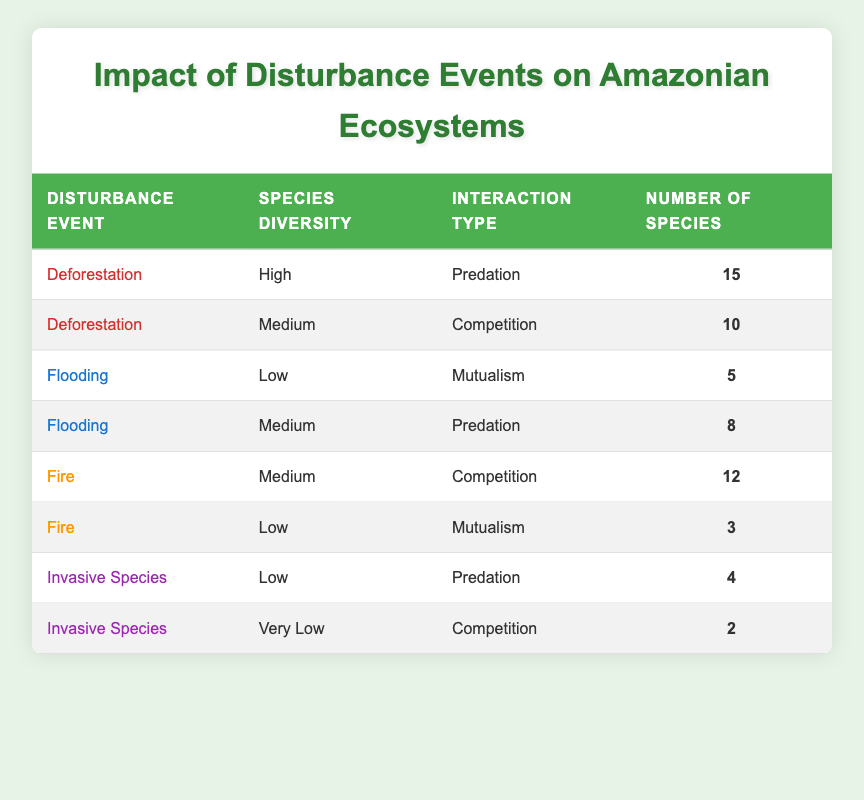What is the number of species associated with the Deforestation event and Predation interaction type? To find the answer, look for the row in the table under Deforestation for the Interaction Type of Predation. That row indicates there are 15 species.
Answer: 15 How many species are involved in the Medium Species Diversity category under Flooding? Check the rows under Flooding for the Species Diversity category labeled Medium. There is one row corresponding to this, showing that there are 8 species.
Answer: 8 Is there a higher number of species recorded under Fire for Competition or Mutualism interaction types? Review the rows for Fire. The Competition interaction shows 12 species while Mutualism shows only 3 species. Therefore, 12 is greater than 3.
Answer: Competition How many species are recorded across all categories for the Invasive Species disturbance event? For the Invasive Species event, look at the number of species in both rows. Adding these together (4 from Predation and 2 from Competition) gives a total of 6 species.
Answer: 6 What is the diversity status of species associated with Flooding and Mutualism? Look at the row under Flooding with the Interaction Type of Mutualism. The corresponding Species Diversity is labeled Low.
Answer: Low What is the average number of species across all disturbance events for those that fall within the Low Species Diversity category? Identify the rows where Species Diversity is Low. These are Flooding (5 species), Fire (3 species), and Invasive Species (4 species). Sum these values to get a total of 12 species (5 + 3 + 4). There are 3 data points, and dividing gives an average of 12/3 = 4.
Answer: 4 Is there any disturbance event that shows High species diversity? Check the table for any events under the Species Diversity labeled High. There is only one instance under Deforestation that confirms this.
Answer: Yes How many species have a Very Low Species Diversity under the Invasive Species event? Look at the row for Invasive Species with Very Low Species Diversity. That row indicates there are 2 species involved.
Answer: 2 Which disturbance event has the highest number of species in the table, and what is that number? Review all rows in the table for the highest value in the Number of Species column. The Deforestation event's Predation interaction shows 15 species, which is higher than all other events.
Answer: Deforestation, 15 